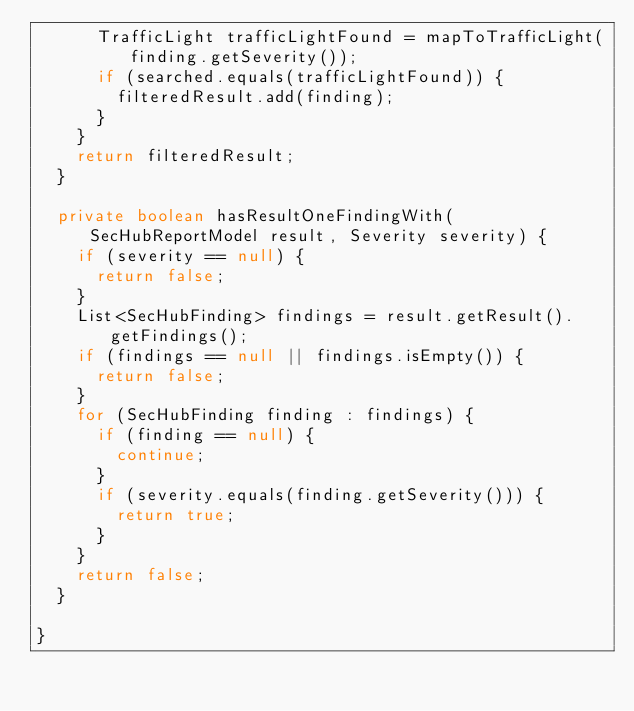Convert code to text. <code><loc_0><loc_0><loc_500><loc_500><_Java_>			TrafficLight trafficLightFound = mapToTrafficLight(finding.getSeverity());
			if (searched.equals(trafficLightFound)) {
				filteredResult.add(finding);
			}
		}
		return filteredResult;
	}

	private boolean hasResultOneFindingWith(SecHubReportModel result, Severity severity) {
		if (severity == null) {
			return false;
		}
		List<SecHubFinding> findings = result.getResult().getFindings();
		if (findings == null || findings.isEmpty()) {
			return false;
		}
		for (SecHubFinding finding : findings) {
			if (finding == null) {
				continue;
			}
			if (severity.equals(finding.getSeverity())) {
				return true;
			}
		}
		return false;
	}

}
</code> 